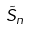Convert formula to latex. <formula><loc_0><loc_0><loc_500><loc_500>\tilde { S } _ { n }</formula> 